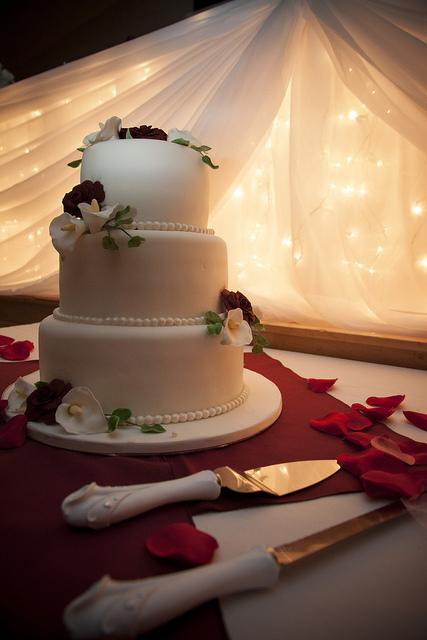Which kind of relationship is this cake typically designed for? wedding 